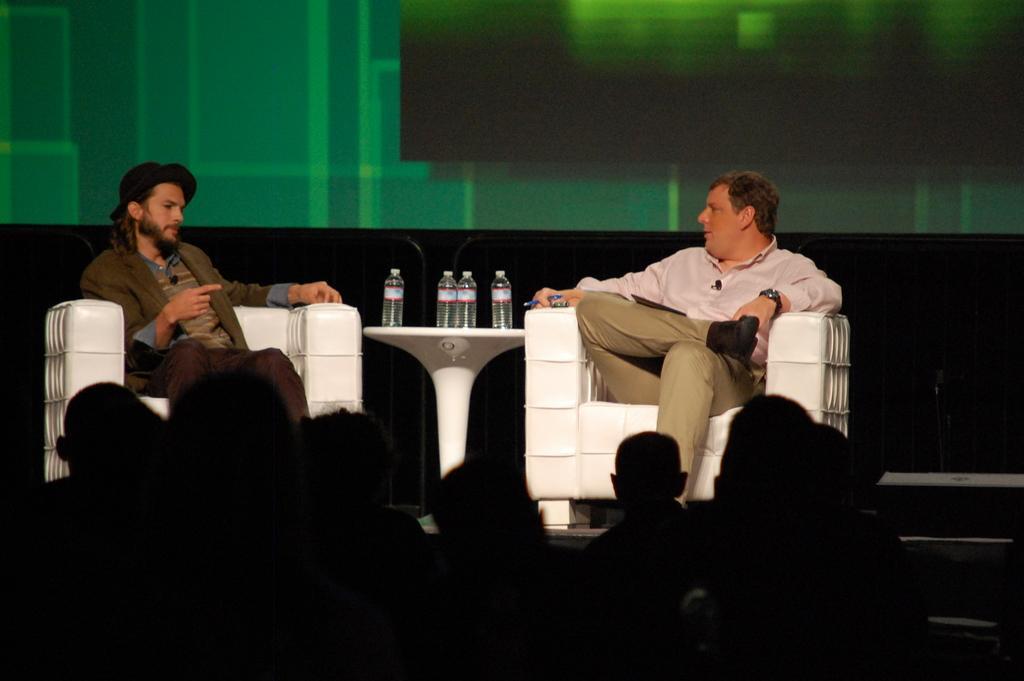Can you describe this image briefly? In the center of the image there are two people sitting on the couch in between them there is a stand and bottles placed on the stand. At the bottom of the image there is a crowd. 